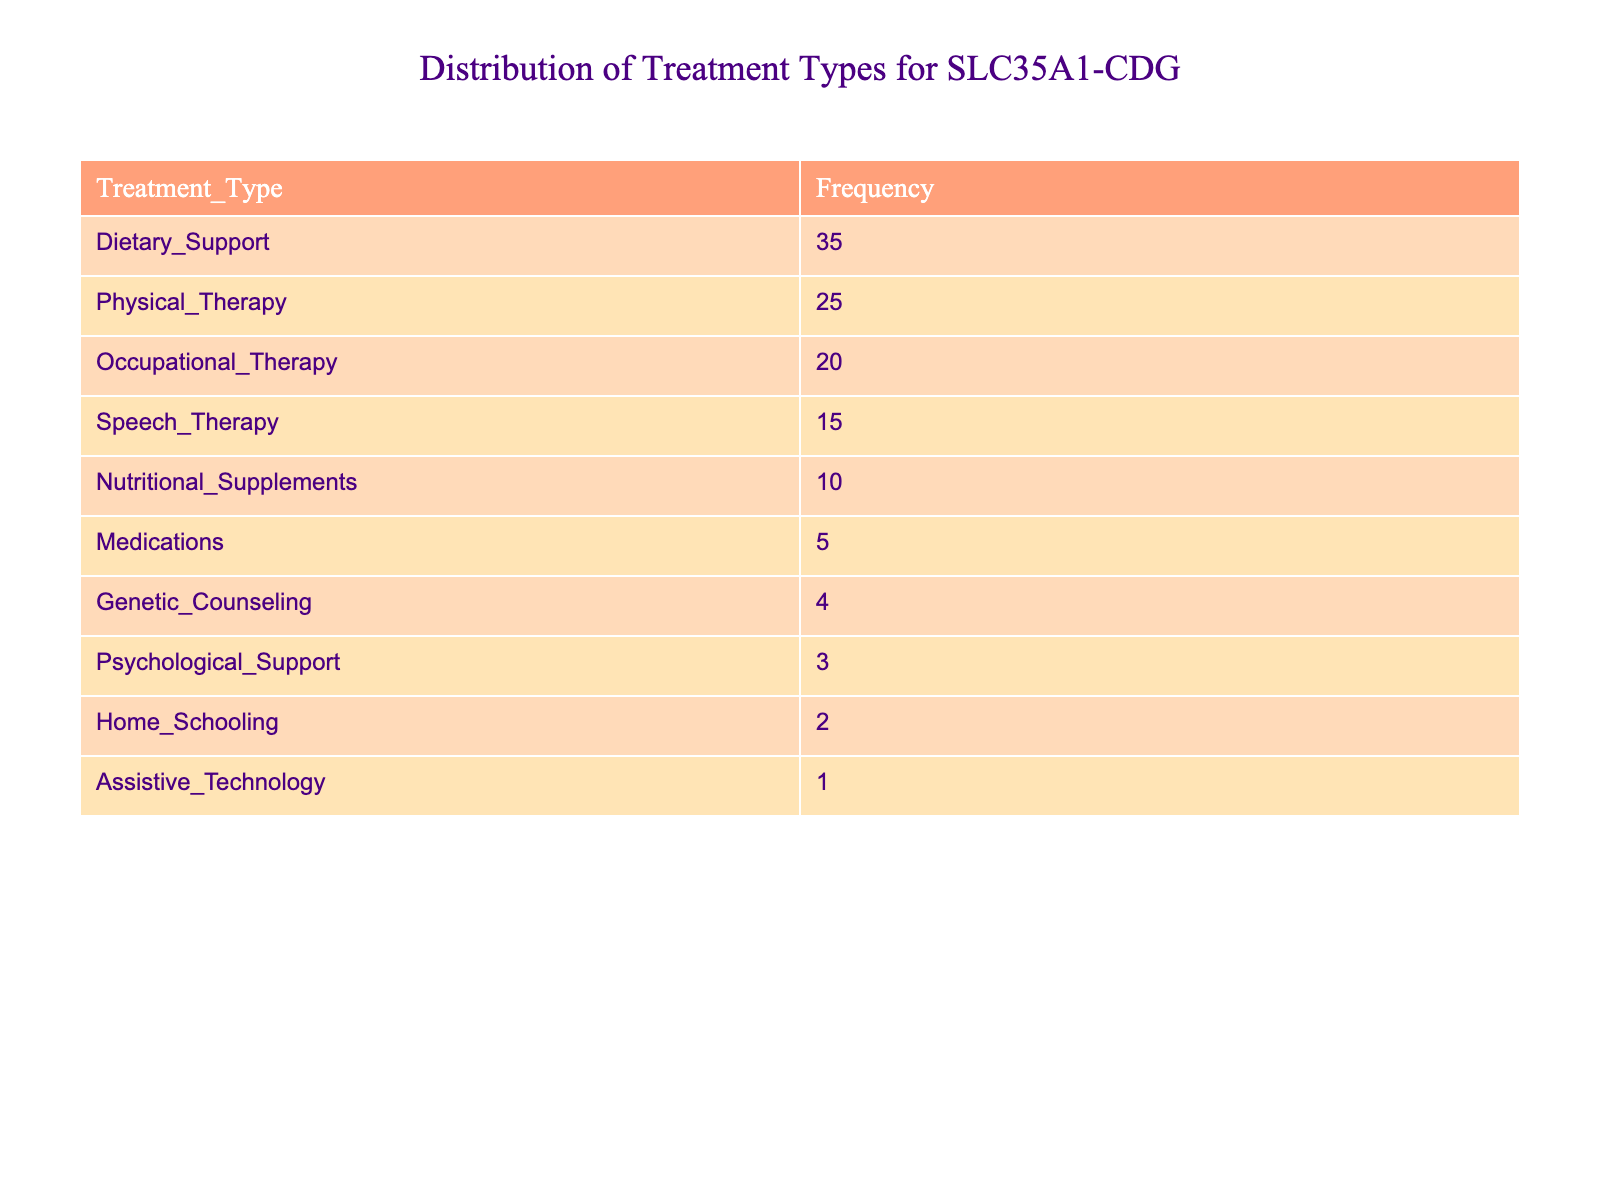What is the frequency of Dietary Support? The table lists Dietary Support with a frequency of 35.
Answer: 35 How many more instances of Physical Therapy are there compared to Genetic Counseling? Physical Therapy has a frequency of 25, and Genetic Counseling has a frequency of 4. The difference is 25 - 4 = 21.
Answer: 21 Is there a treatment type with a frequency of 2? The table shows Home Schooling with a frequency of 2. Thus, the statement is true.
Answer: Yes What treatment type has the lowest frequency? The treatment with the lowest frequency in the table is Assistive Technology, which has a frequency of 1.
Answer: Assistive Technology What is the total frequency of all treatment types listed? To find the total frequency, add all the values: 35 + 25 + 20 + 15 + 10 + 5 + 4 + 3 + 2 + 1 = 120.
Answer: 120 Which treatment type has a frequency greater than 15 but less than 30? From the table, the treatment type that meets this condition is Physical Therapy, which has a frequency of 25.
Answer: Physical Therapy Is the frequency of Nutritional Supplements greater than or equal to the frequency of Medications? Nutritional Supplements has a frequency of 10, while Medications has a frequency of 5. Since 10 is greater than 5, the statement is true.
Answer: Yes How many treatments have a frequency of 10 or more? The treatments with frequencies of 10 or more are Dietary Support (35), Physical Therapy (25), Occupational Therapy (20), and Nutritional Supplements (10). This makes a total of 4 treatment types.
Answer: 4 What is the average frequency of the treatments provided? To find the average, sum all treatment frequencies (120) and divide by the number of treatments (10): 120 / 10 = 12.
Answer: 12 